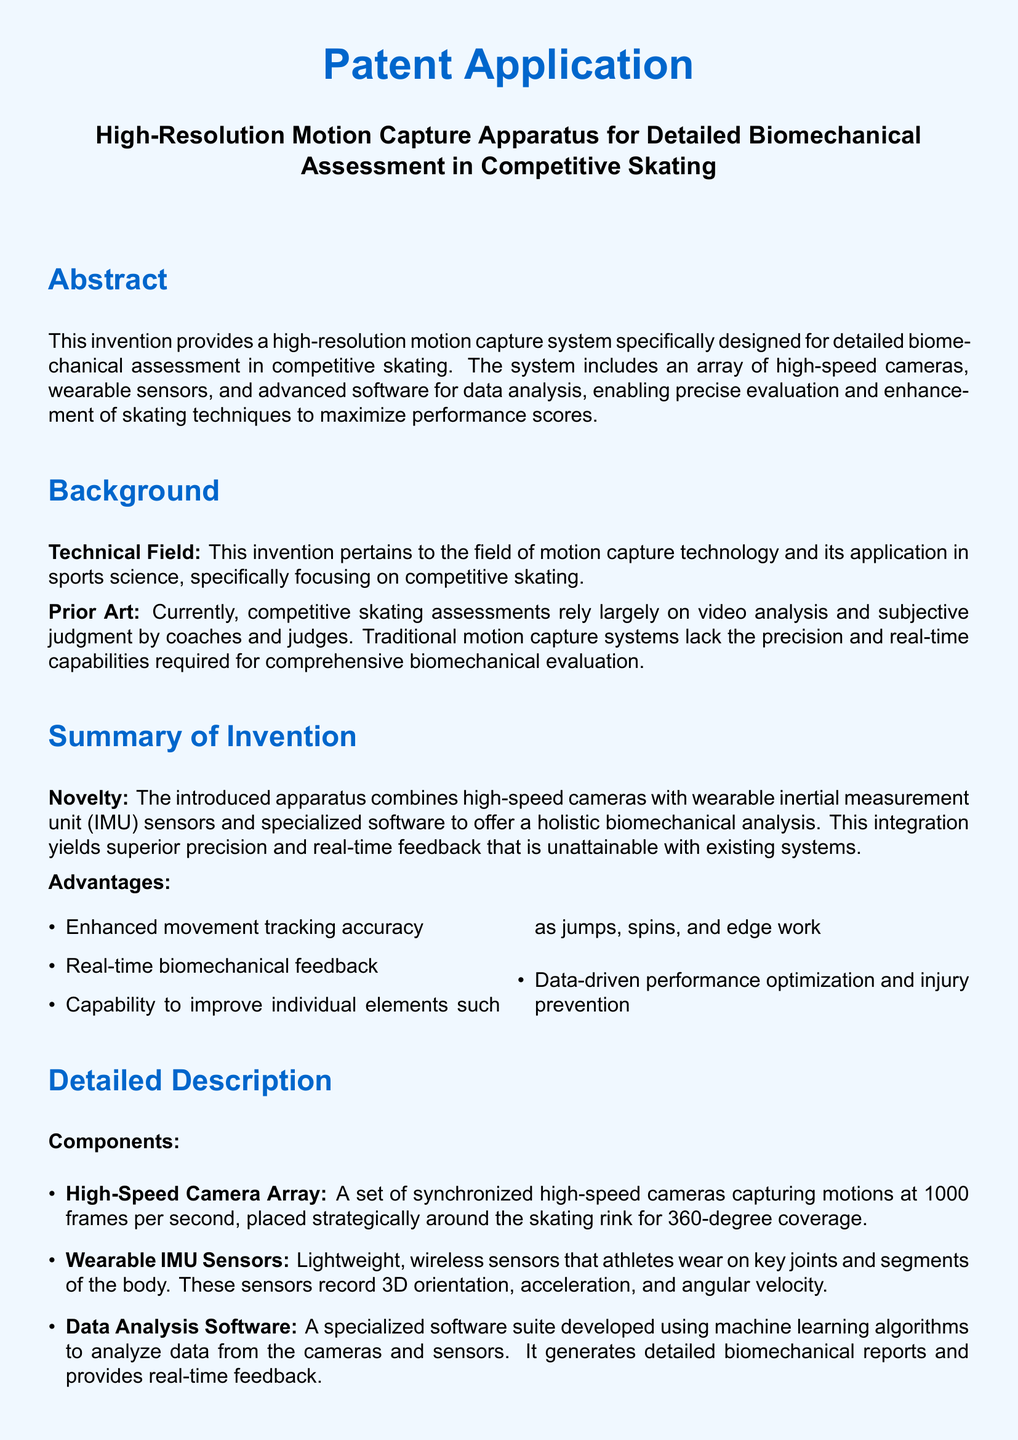what is the main purpose of the invention? The purpose is to provide a high-resolution motion capture system for detailed biomechanical assessment in competitive skating.
Answer: high-resolution motion capture system how many frames per second do the high-speed cameras capture? The high-speed cameras are specified to capture motions at 1000 frames per second.
Answer: 1000 frames per second what type of sensors are used in the apparatus? The apparatus includes wearable inertial measurement unit (IMU) sensors.
Answer: inertial measurement unit (IMU) sensors what is one advantage of the introduced apparatus? One advantage mentioned is enhanced movement tracking accuracy.
Answer: enhanced movement tracking accuracy which algorithm type is utilized by the software suite? The software suite employs machine learning algorithms for data analysis.
Answer: machine learning algorithms what does the term 'claims' refer to in the document? The term 'claims' encapsulates the specific features and components of the invention being patented.
Answer: specific features and components how does the system provide feedback to the athlete? The system provides instant biomechanical feedback to the athlete and coach after analyzing the captured data.
Answer: instant biomechanical feedback what is the color scheme highlighted in the document's design? The document highlights a color scheme featuring skateblue and icegray.
Answer: skateblue and icegray 